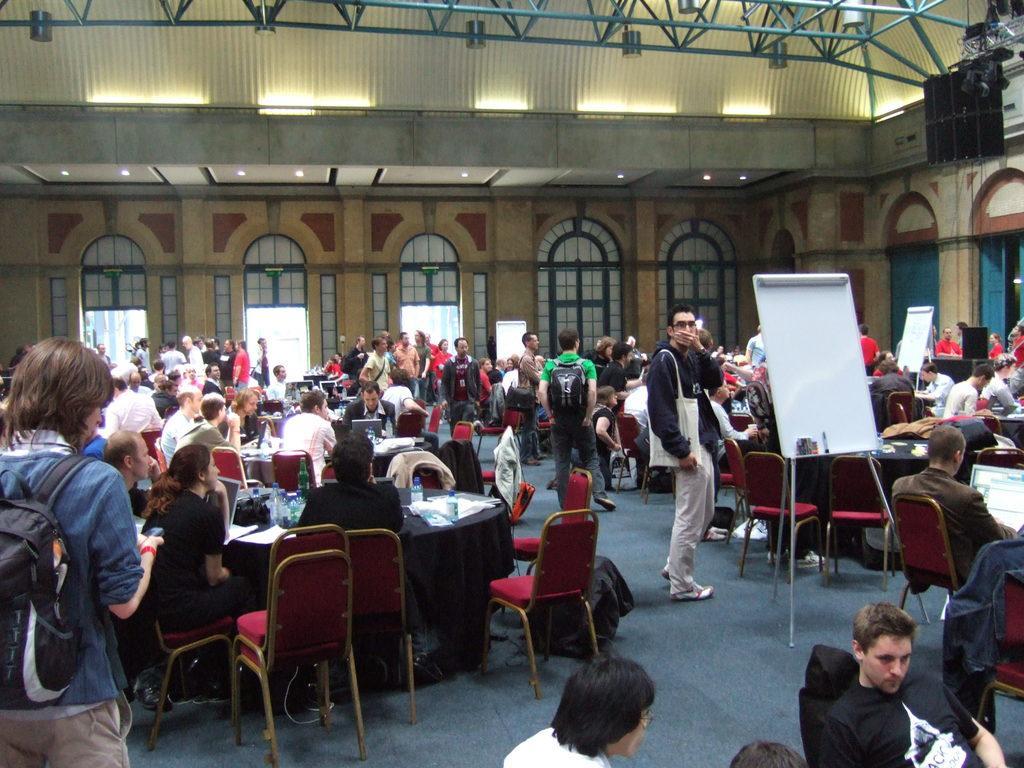Could you give a brief overview of what you see in this image? In the middle a man is standing and here a group of people are sitting around the chairs. 